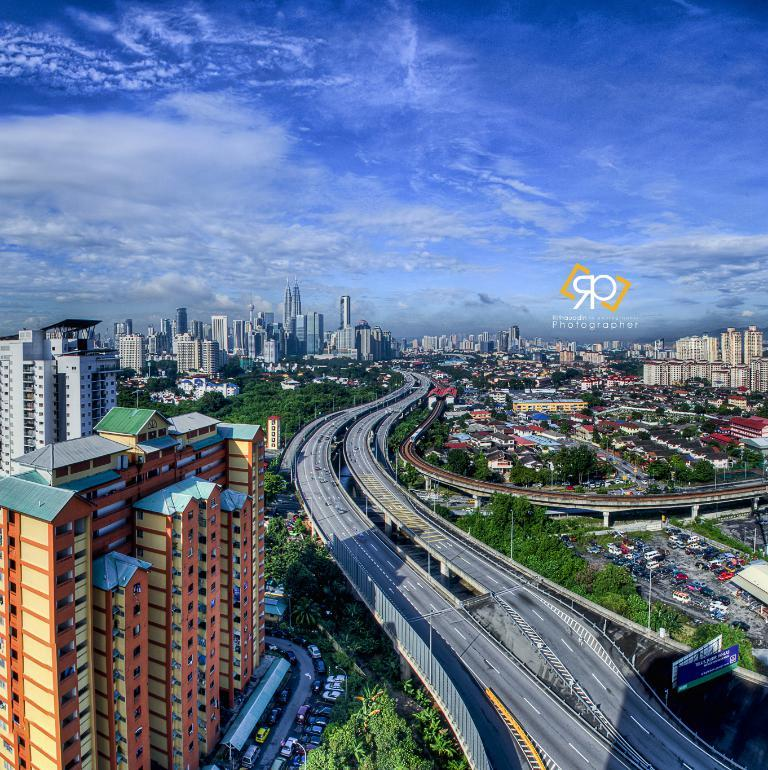What type of structures can be seen in the image? There are buildings, sheds, and sign boards in the image. What features are present on the buildings? There are windows on the buildings. What type of transportation is visible in the image? There are vehicles in the image. What type of pathways are present in the image? There are roads in the image. What type of vegetation can be seen in the image? There are trees in the image. What type of support structures are present in the image? There are poles in the image. What is the color of the sky in the image? The sky is blue and white in color. Can you tell me how many times the person in the image regrets their decision? There is no person present in the image, and therefore no decision-making or regret can be observed. What type of edge can be seen on the buildings in the image? The buildings in the image do not have any specific edges mentioned in the provided facts, so it cannot be determined from the image. 